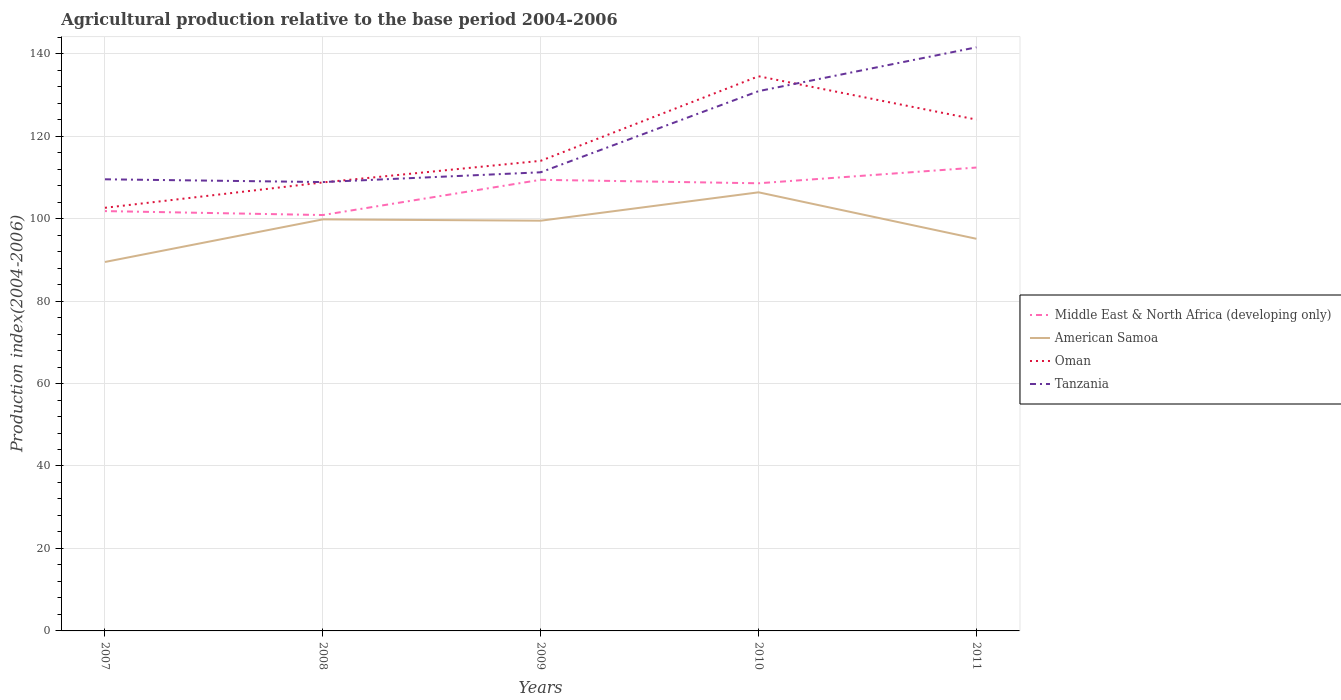How many different coloured lines are there?
Your answer should be compact. 4. Is the number of lines equal to the number of legend labels?
Your answer should be compact. Yes. Across all years, what is the maximum agricultural production index in American Samoa?
Offer a terse response. 89.48. What is the total agricultural production index in Oman in the graph?
Give a very brief answer. -5.24. What is the difference between the highest and the second highest agricultural production index in Tanzania?
Your response must be concise. 32.68. Is the agricultural production index in American Samoa strictly greater than the agricultural production index in Tanzania over the years?
Your response must be concise. Yes. How many lines are there?
Offer a terse response. 4. Does the graph contain any zero values?
Keep it short and to the point. No. Where does the legend appear in the graph?
Ensure brevity in your answer.  Center right. How many legend labels are there?
Provide a short and direct response. 4. What is the title of the graph?
Provide a short and direct response. Agricultural production relative to the base period 2004-2006. What is the label or title of the X-axis?
Your response must be concise. Years. What is the label or title of the Y-axis?
Keep it short and to the point. Production index(2004-2006). What is the Production index(2004-2006) in Middle East & North Africa (developing only) in 2007?
Provide a short and direct response. 101.82. What is the Production index(2004-2006) of American Samoa in 2007?
Give a very brief answer. 89.48. What is the Production index(2004-2006) in Oman in 2007?
Your answer should be compact. 102.62. What is the Production index(2004-2006) in Tanzania in 2007?
Provide a succinct answer. 109.53. What is the Production index(2004-2006) of Middle East & North Africa (developing only) in 2008?
Your answer should be very brief. 100.86. What is the Production index(2004-2006) of American Samoa in 2008?
Give a very brief answer. 99.81. What is the Production index(2004-2006) in Oman in 2008?
Provide a succinct answer. 108.77. What is the Production index(2004-2006) of Tanzania in 2008?
Provide a succinct answer. 108.86. What is the Production index(2004-2006) of Middle East & North Africa (developing only) in 2009?
Keep it short and to the point. 109.41. What is the Production index(2004-2006) of American Samoa in 2009?
Your response must be concise. 99.49. What is the Production index(2004-2006) in Oman in 2009?
Offer a very short reply. 114.01. What is the Production index(2004-2006) of Tanzania in 2009?
Offer a very short reply. 111.23. What is the Production index(2004-2006) in Middle East & North Africa (developing only) in 2010?
Provide a short and direct response. 108.56. What is the Production index(2004-2006) of American Samoa in 2010?
Give a very brief answer. 106.37. What is the Production index(2004-2006) in Oman in 2010?
Your answer should be compact. 134.52. What is the Production index(2004-2006) in Tanzania in 2010?
Offer a very short reply. 130.91. What is the Production index(2004-2006) in Middle East & North Africa (developing only) in 2011?
Give a very brief answer. 112.38. What is the Production index(2004-2006) of American Samoa in 2011?
Give a very brief answer. 95.1. What is the Production index(2004-2006) of Oman in 2011?
Keep it short and to the point. 124.01. What is the Production index(2004-2006) of Tanzania in 2011?
Give a very brief answer. 141.54. Across all years, what is the maximum Production index(2004-2006) in Middle East & North Africa (developing only)?
Make the answer very short. 112.38. Across all years, what is the maximum Production index(2004-2006) of American Samoa?
Make the answer very short. 106.37. Across all years, what is the maximum Production index(2004-2006) in Oman?
Give a very brief answer. 134.52. Across all years, what is the maximum Production index(2004-2006) in Tanzania?
Ensure brevity in your answer.  141.54. Across all years, what is the minimum Production index(2004-2006) of Middle East & North Africa (developing only)?
Keep it short and to the point. 100.86. Across all years, what is the minimum Production index(2004-2006) of American Samoa?
Keep it short and to the point. 89.48. Across all years, what is the minimum Production index(2004-2006) in Oman?
Give a very brief answer. 102.62. Across all years, what is the minimum Production index(2004-2006) of Tanzania?
Offer a very short reply. 108.86. What is the total Production index(2004-2006) of Middle East & North Africa (developing only) in the graph?
Provide a succinct answer. 533.03. What is the total Production index(2004-2006) in American Samoa in the graph?
Your answer should be very brief. 490.25. What is the total Production index(2004-2006) in Oman in the graph?
Your response must be concise. 583.93. What is the total Production index(2004-2006) of Tanzania in the graph?
Provide a short and direct response. 602.07. What is the difference between the Production index(2004-2006) of Middle East & North Africa (developing only) in 2007 and that in 2008?
Your answer should be very brief. 0.96. What is the difference between the Production index(2004-2006) in American Samoa in 2007 and that in 2008?
Your answer should be compact. -10.33. What is the difference between the Production index(2004-2006) of Oman in 2007 and that in 2008?
Offer a terse response. -6.15. What is the difference between the Production index(2004-2006) of Tanzania in 2007 and that in 2008?
Provide a short and direct response. 0.67. What is the difference between the Production index(2004-2006) of Middle East & North Africa (developing only) in 2007 and that in 2009?
Give a very brief answer. -7.59. What is the difference between the Production index(2004-2006) in American Samoa in 2007 and that in 2009?
Offer a very short reply. -10.01. What is the difference between the Production index(2004-2006) of Oman in 2007 and that in 2009?
Ensure brevity in your answer.  -11.39. What is the difference between the Production index(2004-2006) in Middle East & North Africa (developing only) in 2007 and that in 2010?
Ensure brevity in your answer.  -6.75. What is the difference between the Production index(2004-2006) in American Samoa in 2007 and that in 2010?
Provide a succinct answer. -16.89. What is the difference between the Production index(2004-2006) in Oman in 2007 and that in 2010?
Provide a succinct answer. -31.9. What is the difference between the Production index(2004-2006) in Tanzania in 2007 and that in 2010?
Provide a succinct answer. -21.38. What is the difference between the Production index(2004-2006) of Middle East & North Africa (developing only) in 2007 and that in 2011?
Ensure brevity in your answer.  -10.56. What is the difference between the Production index(2004-2006) in American Samoa in 2007 and that in 2011?
Give a very brief answer. -5.62. What is the difference between the Production index(2004-2006) of Oman in 2007 and that in 2011?
Your response must be concise. -21.39. What is the difference between the Production index(2004-2006) in Tanzania in 2007 and that in 2011?
Your response must be concise. -32.01. What is the difference between the Production index(2004-2006) in Middle East & North Africa (developing only) in 2008 and that in 2009?
Provide a short and direct response. -8.54. What is the difference between the Production index(2004-2006) of American Samoa in 2008 and that in 2009?
Your answer should be compact. 0.32. What is the difference between the Production index(2004-2006) in Oman in 2008 and that in 2009?
Give a very brief answer. -5.24. What is the difference between the Production index(2004-2006) of Tanzania in 2008 and that in 2009?
Your response must be concise. -2.37. What is the difference between the Production index(2004-2006) of Middle East & North Africa (developing only) in 2008 and that in 2010?
Keep it short and to the point. -7.7. What is the difference between the Production index(2004-2006) in American Samoa in 2008 and that in 2010?
Your response must be concise. -6.56. What is the difference between the Production index(2004-2006) of Oman in 2008 and that in 2010?
Provide a short and direct response. -25.75. What is the difference between the Production index(2004-2006) in Tanzania in 2008 and that in 2010?
Provide a succinct answer. -22.05. What is the difference between the Production index(2004-2006) in Middle East & North Africa (developing only) in 2008 and that in 2011?
Your answer should be very brief. -11.52. What is the difference between the Production index(2004-2006) in American Samoa in 2008 and that in 2011?
Give a very brief answer. 4.71. What is the difference between the Production index(2004-2006) of Oman in 2008 and that in 2011?
Your answer should be very brief. -15.24. What is the difference between the Production index(2004-2006) of Tanzania in 2008 and that in 2011?
Keep it short and to the point. -32.68. What is the difference between the Production index(2004-2006) of Middle East & North Africa (developing only) in 2009 and that in 2010?
Keep it short and to the point. 0.84. What is the difference between the Production index(2004-2006) in American Samoa in 2009 and that in 2010?
Offer a very short reply. -6.88. What is the difference between the Production index(2004-2006) in Oman in 2009 and that in 2010?
Keep it short and to the point. -20.51. What is the difference between the Production index(2004-2006) in Tanzania in 2009 and that in 2010?
Offer a very short reply. -19.68. What is the difference between the Production index(2004-2006) of Middle East & North Africa (developing only) in 2009 and that in 2011?
Your answer should be very brief. -2.98. What is the difference between the Production index(2004-2006) of American Samoa in 2009 and that in 2011?
Give a very brief answer. 4.39. What is the difference between the Production index(2004-2006) of Oman in 2009 and that in 2011?
Your response must be concise. -10. What is the difference between the Production index(2004-2006) of Tanzania in 2009 and that in 2011?
Offer a terse response. -30.31. What is the difference between the Production index(2004-2006) of Middle East & North Africa (developing only) in 2010 and that in 2011?
Offer a very short reply. -3.82. What is the difference between the Production index(2004-2006) in American Samoa in 2010 and that in 2011?
Your response must be concise. 11.27. What is the difference between the Production index(2004-2006) of Oman in 2010 and that in 2011?
Offer a terse response. 10.51. What is the difference between the Production index(2004-2006) in Tanzania in 2010 and that in 2011?
Keep it short and to the point. -10.63. What is the difference between the Production index(2004-2006) of Middle East & North Africa (developing only) in 2007 and the Production index(2004-2006) of American Samoa in 2008?
Your answer should be compact. 2.01. What is the difference between the Production index(2004-2006) of Middle East & North Africa (developing only) in 2007 and the Production index(2004-2006) of Oman in 2008?
Your answer should be compact. -6.95. What is the difference between the Production index(2004-2006) in Middle East & North Africa (developing only) in 2007 and the Production index(2004-2006) in Tanzania in 2008?
Offer a very short reply. -7.04. What is the difference between the Production index(2004-2006) in American Samoa in 2007 and the Production index(2004-2006) in Oman in 2008?
Offer a very short reply. -19.29. What is the difference between the Production index(2004-2006) of American Samoa in 2007 and the Production index(2004-2006) of Tanzania in 2008?
Your response must be concise. -19.38. What is the difference between the Production index(2004-2006) in Oman in 2007 and the Production index(2004-2006) in Tanzania in 2008?
Your response must be concise. -6.24. What is the difference between the Production index(2004-2006) of Middle East & North Africa (developing only) in 2007 and the Production index(2004-2006) of American Samoa in 2009?
Ensure brevity in your answer.  2.33. What is the difference between the Production index(2004-2006) of Middle East & North Africa (developing only) in 2007 and the Production index(2004-2006) of Oman in 2009?
Your answer should be compact. -12.19. What is the difference between the Production index(2004-2006) in Middle East & North Africa (developing only) in 2007 and the Production index(2004-2006) in Tanzania in 2009?
Provide a short and direct response. -9.41. What is the difference between the Production index(2004-2006) of American Samoa in 2007 and the Production index(2004-2006) of Oman in 2009?
Give a very brief answer. -24.53. What is the difference between the Production index(2004-2006) of American Samoa in 2007 and the Production index(2004-2006) of Tanzania in 2009?
Offer a very short reply. -21.75. What is the difference between the Production index(2004-2006) of Oman in 2007 and the Production index(2004-2006) of Tanzania in 2009?
Provide a short and direct response. -8.61. What is the difference between the Production index(2004-2006) in Middle East & North Africa (developing only) in 2007 and the Production index(2004-2006) in American Samoa in 2010?
Ensure brevity in your answer.  -4.55. What is the difference between the Production index(2004-2006) in Middle East & North Africa (developing only) in 2007 and the Production index(2004-2006) in Oman in 2010?
Make the answer very short. -32.7. What is the difference between the Production index(2004-2006) of Middle East & North Africa (developing only) in 2007 and the Production index(2004-2006) of Tanzania in 2010?
Keep it short and to the point. -29.09. What is the difference between the Production index(2004-2006) in American Samoa in 2007 and the Production index(2004-2006) in Oman in 2010?
Your answer should be compact. -45.04. What is the difference between the Production index(2004-2006) of American Samoa in 2007 and the Production index(2004-2006) of Tanzania in 2010?
Provide a succinct answer. -41.43. What is the difference between the Production index(2004-2006) of Oman in 2007 and the Production index(2004-2006) of Tanzania in 2010?
Make the answer very short. -28.29. What is the difference between the Production index(2004-2006) in Middle East & North Africa (developing only) in 2007 and the Production index(2004-2006) in American Samoa in 2011?
Your answer should be very brief. 6.72. What is the difference between the Production index(2004-2006) of Middle East & North Africa (developing only) in 2007 and the Production index(2004-2006) of Oman in 2011?
Provide a succinct answer. -22.19. What is the difference between the Production index(2004-2006) of Middle East & North Africa (developing only) in 2007 and the Production index(2004-2006) of Tanzania in 2011?
Provide a short and direct response. -39.72. What is the difference between the Production index(2004-2006) of American Samoa in 2007 and the Production index(2004-2006) of Oman in 2011?
Ensure brevity in your answer.  -34.53. What is the difference between the Production index(2004-2006) of American Samoa in 2007 and the Production index(2004-2006) of Tanzania in 2011?
Offer a terse response. -52.06. What is the difference between the Production index(2004-2006) of Oman in 2007 and the Production index(2004-2006) of Tanzania in 2011?
Provide a succinct answer. -38.92. What is the difference between the Production index(2004-2006) in Middle East & North Africa (developing only) in 2008 and the Production index(2004-2006) in American Samoa in 2009?
Provide a short and direct response. 1.37. What is the difference between the Production index(2004-2006) of Middle East & North Africa (developing only) in 2008 and the Production index(2004-2006) of Oman in 2009?
Offer a very short reply. -13.15. What is the difference between the Production index(2004-2006) of Middle East & North Africa (developing only) in 2008 and the Production index(2004-2006) of Tanzania in 2009?
Your answer should be very brief. -10.37. What is the difference between the Production index(2004-2006) in American Samoa in 2008 and the Production index(2004-2006) in Tanzania in 2009?
Offer a terse response. -11.42. What is the difference between the Production index(2004-2006) in Oman in 2008 and the Production index(2004-2006) in Tanzania in 2009?
Ensure brevity in your answer.  -2.46. What is the difference between the Production index(2004-2006) in Middle East & North Africa (developing only) in 2008 and the Production index(2004-2006) in American Samoa in 2010?
Your answer should be very brief. -5.51. What is the difference between the Production index(2004-2006) in Middle East & North Africa (developing only) in 2008 and the Production index(2004-2006) in Oman in 2010?
Give a very brief answer. -33.66. What is the difference between the Production index(2004-2006) of Middle East & North Africa (developing only) in 2008 and the Production index(2004-2006) of Tanzania in 2010?
Offer a terse response. -30.05. What is the difference between the Production index(2004-2006) of American Samoa in 2008 and the Production index(2004-2006) of Oman in 2010?
Offer a very short reply. -34.71. What is the difference between the Production index(2004-2006) of American Samoa in 2008 and the Production index(2004-2006) of Tanzania in 2010?
Provide a short and direct response. -31.1. What is the difference between the Production index(2004-2006) of Oman in 2008 and the Production index(2004-2006) of Tanzania in 2010?
Make the answer very short. -22.14. What is the difference between the Production index(2004-2006) in Middle East & North Africa (developing only) in 2008 and the Production index(2004-2006) in American Samoa in 2011?
Your answer should be very brief. 5.76. What is the difference between the Production index(2004-2006) in Middle East & North Africa (developing only) in 2008 and the Production index(2004-2006) in Oman in 2011?
Your answer should be compact. -23.15. What is the difference between the Production index(2004-2006) in Middle East & North Africa (developing only) in 2008 and the Production index(2004-2006) in Tanzania in 2011?
Make the answer very short. -40.68. What is the difference between the Production index(2004-2006) in American Samoa in 2008 and the Production index(2004-2006) in Oman in 2011?
Your response must be concise. -24.2. What is the difference between the Production index(2004-2006) of American Samoa in 2008 and the Production index(2004-2006) of Tanzania in 2011?
Keep it short and to the point. -41.73. What is the difference between the Production index(2004-2006) in Oman in 2008 and the Production index(2004-2006) in Tanzania in 2011?
Your response must be concise. -32.77. What is the difference between the Production index(2004-2006) of Middle East & North Africa (developing only) in 2009 and the Production index(2004-2006) of American Samoa in 2010?
Ensure brevity in your answer.  3.04. What is the difference between the Production index(2004-2006) of Middle East & North Africa (developing only) in 2009 and the Production index(2004-2006) of Oman in 2010?
Ensure brevity in your answer.  -25.11. What is the difference between the Production index(2004-2006) of Middle East & North Africa (developing only) in 2009 and the Production index(2004-2006) of Tanzania in 2010?
Your answer should be very brief. -21.5. What is the difference between the Production index(2004-2006) in American Samoa in 2009 and the Production index(2004-2006) in Oman in 2010?
Offer a terse response. -35.03. What is the difference between the Production index(2004-2006) in American Samoa in 2009 and the Production index(2004-2006) in Tanzania in 2010?
Keep it short and to the point. -31.42. What is the difference between the Production index(2004-2006) in Oman in 2009 and the Production index(2004-2006) in Tanzania in 2010?
Provide a succinct answer. -16.9. What is the difference between the Production index(2004-2006) of Middle East & North Africa (developing only) in 2009 and the Production index(2004-2006) of American Samoa in 2011?
Give a very brief answer. 14.31. What is the difference between the Production index(2004-2006) in Middle East & North Africa (developing only) in 2009 and the Production index(2004-2006) in Oman in 2011?
Provide a short and direct response. -14.6. What is the difference between the Production index(2004-2006) in Middle East & North Africa (developing only) in 2009 and the Production index(2004-2006) in Tanzania in 2011?
Your answer should be compact. -32.13. What is the difference between the Production index(2004-2006) of American Samoa in 2009 and the Production index(2004-2006) of Oman in 2011?
Make the answer very short. -24.52. What is the difference between the Production index(2004-2006) of American Samoa in 2009 and the Production index(2004-2006) of Tanzania in 2011?
Your answer should be very brief. -42.05. What is the difference between the Production index(2004-2006) of Oman in 2009 and the Production index(2004-2006) of Tanzania in 2011?
Keep it short and to the point. -27.53. What is the difference between the Production index(2004-2006) in Middle East & North Africa (developing only) in 2010 and the Production index(2004-2006) in American Samoa in 2011?
Your answer should be compact. 13.46. What is the difference between the Production index(2004-2006) of Middle East & North Africa (developing only) in 2010 and the Production index(2004-2006) of Oman in 2011?
Make the answer very short. -15.45. What is the difference between the Production index(2004-2006) in Middle East & North Africa (developing only) in 2010 and the Production index(2004-2006) in Tanzania in 2011?
Offer a very short reply. -32.98. What is the difference between the Production index(2004-2006) in American Samoa in 2010 and the Production index(2004-2006) in Oman in 2011?
Keep it short and to the point. -17.64. What is the difference between the Production index(2004-2006) of American Samoa in 2010 and the Production index(2004-2006) of Tanzania in 2011?
Give a very brief answer. -35.17. What is the difference between the Production index(2004-2006) of Oman in 2010 and the Production index(2004-2006) of Tanzania in 2011?
Your response must be concise. -7.02. What is the average Production index(2004-2006) of Middle East & North Africa (developing only) per year?
Ensure brevity in your answer.  106.61. What is the average Production index(2004-2006) of American Samoa per year?
Your response must be concise. 98.05. What is the average Production index(2004-2006) of Oman per year?
Your response must be concise. 116.79. What is the average Production index(2004-2006) of Tanzania per year?
Make the answer very short. 120.41. In the year 2007, what is the difference between the Production index(2004-2006) in Middle East & North Africa (developing only) and Production index(2004-2006) in American Samoa?
Keep it short and to the point. 12.34. In the year 2007, what is the difference between the Production index(2004-2006) in Middle East & North Africa (developing only) and Production index(2004-2006) in Oman?
Provide a short and direct response. -0.8. In the year 2007, what is the difference between the Production index(2004-2006) of Middle East & North Africa (developing only) and Production index(2004-2006) of Tanzania?
Make the answer very short. -7.71. In the year 2007, what is the difference between the Production index(2004-2006) in American Samoa and Production index(2004-2006) in Oman?
Provide a short and direct response. -13.14. In the year 2007, what is the difference between the Production index(2004-2006) of American Samoa and Production index(2004-2006) of Tanzania?
Make the answer very short. -20.05. In the year 2007, what is the difference between the Production index(2004-2006) of Oman and Production index(2004-2006) of Tanzania?
Offer a very short reply. -6.91. In the year 2008, what is the difference between the Production index(2004-2006) in Middle East & North Africa (developing only) and Production index(2004-2006) in American Samoa?
Offer a very short reply. 1.05. In the year 2008, what is the difference between the Production index(2004-2006) of Middle East & North Africa (developing only) and Production index(2004-2006) of Oman?
Ensure brevity in your answer.  -7.91. In the year 2008, what is the difference between the Production index(2004-2006) of Middle East & North Africa (developing only) and Production index(2004-2006) of Tanzania?
Offer a terse response. -8. In the year 2008, what is the difference between the Production index(2004-2006) of American Samoa and Production index(2004-2006) of Oman?
Your answer should be compact. -8.96. In the year 2008, what is the difference between the Production index(2004-2006) of American Samoa and Production index(2004-2006) of Tanzania?
Provide a succinct answer. -9.05. In the year 2008, what is the difference between the Production index(2004-2006) of Oman and Production index(2004-2006) of Tanzania?
Ensure brevity in your answer.  -0.09. In the year 2009, what is the difference between the Production index(2004-2006) in Middle East & North Africa (developing only) and Production index(2004-2006) in American Samoa?
Your answer should be compact. 9.92. In the year 2009, what is the difference between the Production index(2004-2006) of Middle East & North Africa (developing only) and Production index(2004-2006) of Oman?
Offer a terse response. -4.6. In the year 2009, what is the difference between the Production index(2004-2006) in Middle East & North Africa (developing only) and Production index(2004-2006) in Tanzania?
Provide a succinct answer. -1.82. In the year 2009, what is the difference between the Production index(2004-2006) in American Samoa and Production index(2004-2006) in Oman?
Offer a very short reply. -14.52. In the year 2009, what is the difference between the Production index(2004-2006) of American Samoa and Production index(2004-2006) of Tanzania?
Make the answer very short. -11.74. In the year 2009, what is the difference between the Production index(2004-2006) in Oman and Production index(2004-2006) in Tanzania?
Make the answer very short. 2.78. In the year 2010, what is the difference between the Production index(2004-2006) in Middle East & North Africa (developing only) and Production index(2004-2006) in American Samoa?
Make the answer very short. 2.19. In the year 2010, what is the difference between the Production index(2004-2006) of Middle East & North Africa (developing only) and Production index(2004-2006) of Oman?
Keep it short and to the point. -25.96. In the year 2010, what is the difference between the Production index(2004-2006) in Middle East & North Africa (developing only) and Production index(2004-2006) in Tanzania?
Your answer should be very brief. -22.35. In the year 2010, what is the difference between the Production index(2004-2006) in American Samoa and Production index(2004-2006) in Oman?
Provide a succinct answer. -28.15. In the year 2010, what is the difference between the Production index(2004-2006) of American Samoa and Production index(2004-2006) of Tanzania?
Your answer should be very brief. -24.54. In the year 2010, what is the difference between the Production index(2004-2006) of Oman and Production index(2004-2006) of Tanzania?
Your response must be concise. 3.61. In the year 2011, what is the difference between the Production index(2004-2006) of Middle East & North Africa (developing only) and Production index(2004-2006) of American Samoa?
Provide a short and direct response. 17.28. In the year 2011, what is the difference between the Production index(2004-2006) of Middle East & North Africa (developing only) and Production index(2004-2006) of Oman?
Offer a terse response. -11.63. In the year 2011, what is the difference between the Production index(2004-2006) of Middle East & North Africa (developing only) and Production index(2004-2006) of Tanzania?
Your response must be concise. -29.16. In the year 2011, what is the difference between the Production index(2004-2006) of American Samoa and Production index(2004-2006) of Oman?
Your answer should be compact. -28.91. In the year 2011, what is the difference between the Production index(2004-2006) in American Samoa and Production index(2004-2006) in Tanzania?
Provide a short and direct response. -46.44. In the year 2011, what is the difference between the Production index(2004-2006) in Oman and Production index(2004-2006) in Tanzania?
Provide a succinct answer. -17.53. What is the ratio of the Production index(2004-2006) of Middle East & North Africa (developing only) in 2007 to that in 2008?
Your response must be concise. 1.01. What is the ratio of the Production index(2004-2006) in American Samoa in 2007 to that in 2008?
Ensure brevity in your answer.  0.9. What is the ratio of the Production index(2004-2006) in Oman in 2007 to that in 2008?
Your answer should be very brief. 0.94. What is the ratio of the Production index(2004-2006) of Middle East & North Africa (developing only) in 2007 to that in 2009?
Ensure brevity in your answer.  0.93. What is the ratio of the Production index(2004-2006) in American Samoa in 2007 to that in 2009?
Offer a terse response. 0.9. What is the ratio of the Production index(2004-2006) of Oman in 2007 to that in 2009?
Offer a very short reply. 0.9. What is the ratio of the Production index(2004-2006) in Tanzania in 2007 to that in 2009?
Your answer should be compact. 0.98. What is the ratio of the Production index(2004-2006) of Middle East & North Africa (developing only) in 2007 to that in 2010?
Your answer should be compact. 0.94. What is the ratio of the Production index(2004-2006) in American Samoa in 2007 to that in 2010?
Provide a short and direct response. 0.84. What is the ratio of the Production index(2004-2006) of Oman in 2007 to that in 2010?
Your response must be concise. 0.76. What is the ratio of the Production index(2004-2006) in Tanzania in 2007 to that in 2010?
Provide a short and direct response. 0.84. What is the ratio of the Production index(2004-2006) in Middle East & North Africa (developing only) in 2007 to that in 2011?
Your answer should be very brief. 0.91. What is the ratio of the Production index(2004-2006) of American Samoa in 2007 to that in 2011?
Provide a succinct answer. 0.94. What is the ratio of the Production index(2004-2006) in Oman in 2007 to that in 2011?
Keep it short and to the point. 0.83. What is the ratio of the Production index(2004-2006) in Tanzania in 2007 to that in 2011?
Make the answer very short. 0.77. What is the ratio of the Production index(2004-2006) of Middle East & North Africa (developing only) in 2008 to that in 2009?
Provide a succinct answer. 0.92. What is the ratio of the Production index(2004-2006) in Oman in 2008 to that in 2009?
Keep it short and to the point. 0.95. What is the ratio of the Production index(2004-2006) in Tanzania in 2008 to that in 2009?
Give a very brief answer. 0.98. What is the ratio of the Production index(2004-2006) in Middle East & North Africa (developing only) in 2008 to that in 2010?
Offer a terse response. 0.93. What is the ratio of the Production index(2004-2006) in American Samoa in 2008 to that in 2010?
Your answer should be compact. 0.94. What is the ratio of the Production index(2004-2006) of Oman in 2008 to that in 2010?
Keep it short and to the point. 0.81. What is the ratio of the Production index(2004-2006) in Tanzania in 2008 to that in 2010?
Make the answer very short. 0.83. What is the ratio of the Production index(2004-2006) in Middle East & North Africa (developing only) in 2008 to that in 2011?
Provide a succinct answer. 0.9. What is the ratio of the Production index(2004-2006) in American Samoa in 2008 to that in 2011?
Your answer should be very brief. 1.05. What is the ratio of the Production index(2004-2006) in Oman in 2008 to that in 2011?
Your response must be concise. 0.88. What is the ratio of the Production index(2004-2006) in Tanzania in 2008 to that in 2011?
Your answer should be compact. 0.77. What is the ratio of the Production index(2004-2006) of Middle East & North Africa (developing only) in 2009 to that in 2010?
Provide a succinct answer. 1.01. What is the ratio of the Production index(2004-2006) of American Samoa in 2009 to that in 2010?
Offer a terse response. 0.94. What is the ratio of the Production index(2004-2006) in Oman in 2009 to that in 2010?
Your answer should be compact. 0.85. What is the ratio of the Production index(2004-2006) of Tanzania in 2009 to that in 2010?
Your answer should be very brief. 0.85. What is the ratio of the Production index(2004-2006) of Middle East & North Africa (developing only) in 2009 to that in 2011?
Offer a terse response. 0.97. What is the ratio of the Production index(2004-2006) of American Samoa in 2009 to that in 2011?
Give a very brief answer. 1.05. What is the ratio of the Production index(2004-2006) in Oman in 2009 to that in 2011?
Make the answer very short. 0.92. What is the ratio of the Production index(2004-2006) in Tanzania in 2009 to that in 2011?
Keep it short and to the point. 0.79. What is the ratio of the Production index(2004-2006) of Middle East & North Africa (developing only) in 2010 to that in 2011?
Your answer should be very brief. 0.97. What is the ratio of the Production index(2004-2006) of American Samoa in 2010 to that in 2011?
Give a very brief answer. 1.12. What is the ratio of the Production index(2004-2006) in Oman in 2010 to that in 2011?
Offer a terse response. 1.08. What is the ratio of the Production index(2004-2006) in Tanzania in 2010 to that in 2011?
Ensure brevity in your answer.  0.92. What is the difference between the highest and the second highest Production index(2004-2006) in Middle East & North Africa (developing only)?
Your response must be concise. 2.98. What is the difference between the highest and the second highest Production index(2004-2006) of American Samoa?
Your answer should be compact. 6.56. What is the difference between the highest and the second highest Production index(2004-2006) in Oman?
Provide a succinct answer. 10.51. What is the difference between the highest and the second highest Production index(2004-2006) in Tanzania?
Provide a short and direct response. 10.63. What is the difference between the highest and the lowest Production index(2004-2006) in Middle East & North Africa (developing only)?
Your answer should be compact. 11.52. What is the difference between the highest and the lowest Production index(2004-2006) in American Samoa?
Provide a succinct answer. 16.89. What is the difference between the highest and the lowest Production index(2004-2006) in Oman?
Your response must be concise. 31.9. What is the difference between the highest and the lowest Production index(2004-2006) of Tanzania?
Your answer should be compact. 32.68. 